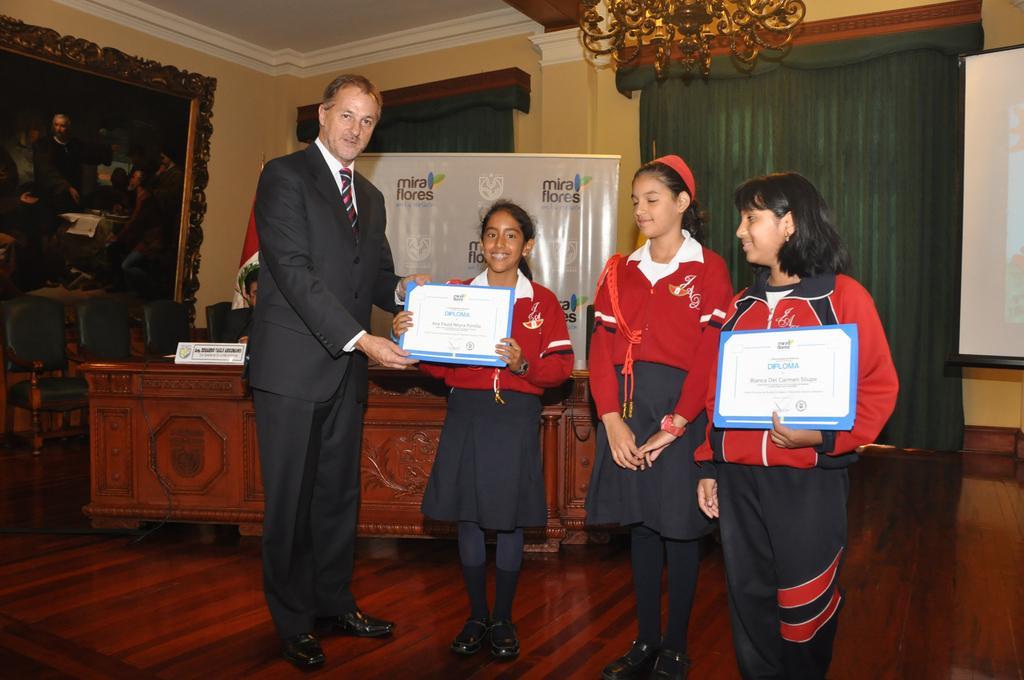How would you summarize this image in a sentence or two? In this image there are three persons standing and holding the certificates , a person standing, a person sitting on a chair, flag, table, name board, banner, screen, chairs, curtains, chandelier, frame attached to the wall. 